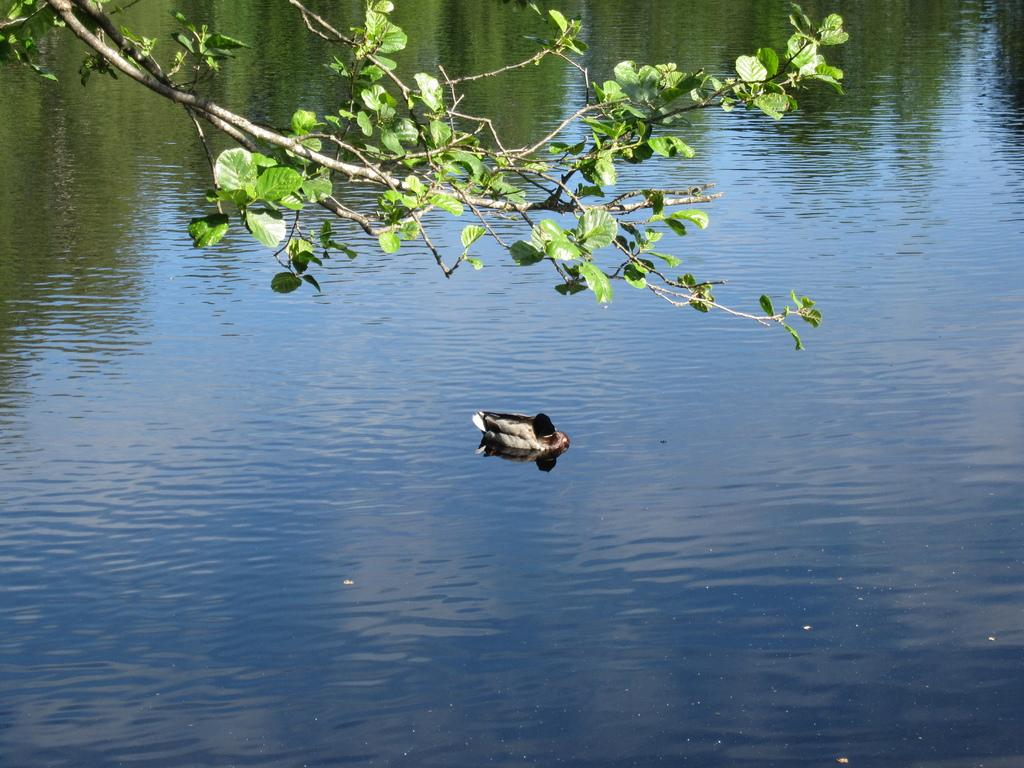What is on the surface of the water in the image? There is a bird on the surface of the water in the image. What type of vegetation can be seen in the image? Leaves are visible in the image. What part of the plants can be seen at the top of the image? Stems are present at the top of the image. What type of hole can be seen in the image? There is no hole present in the image. What type of servant is attending to the bird in the image? There is no servant present in the image; it is a bird on the water. What type of scarf is draped over the leaves in the image? There is no scarf present in the image; only leaves and stems are visible. 